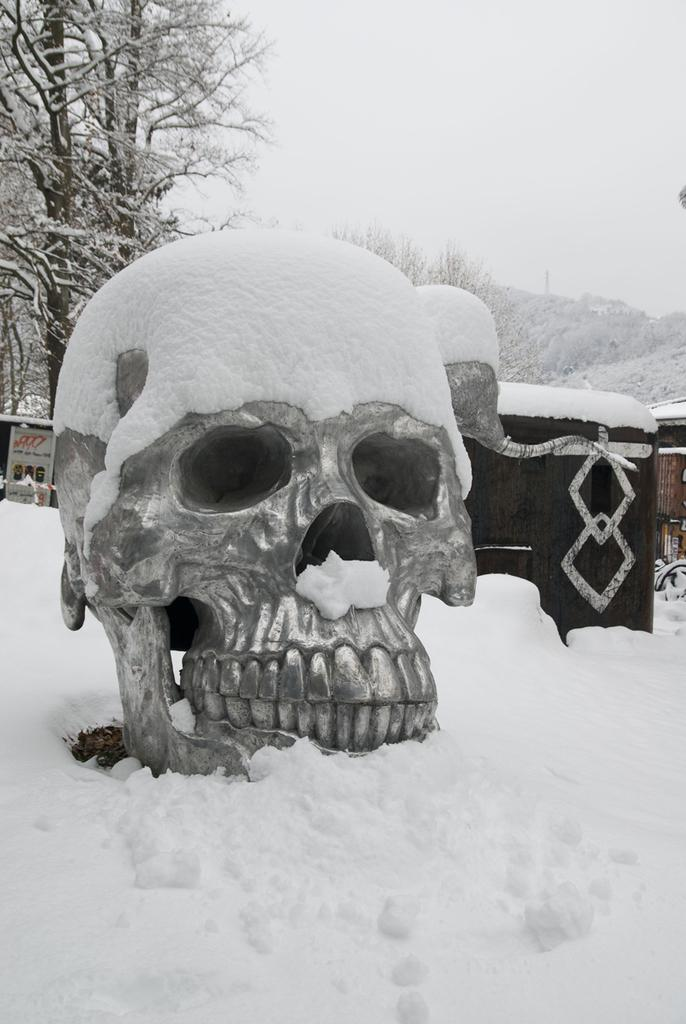What is the main subject of the image? There is a skull in the image. What is covering the skull? The skull has snow on it. What type of structure can be seen in the image? There is a building in the image. What object is present with writing on it? There is a board in the image with writing on it. What type of vegetation is visible in the image? There are trees in the image. What is the overall weather condition in the image? Snow is visible in the image, indicating a snowy environment. What type of nerve can be seen in the image? There are no nerves visible in the image; the image features a skull with snow on it, a building, a board with writing, trees, and snow. What level of difficulty is indicated by the writing on the board? The image does not provide any information about the level of difficulty of the writing on the board. 